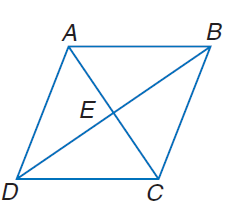Answer the mathemtical geometry problem and directly provide the correct option letter.
Question: In rhombus A B C D, A B = 2 x + 3 and B C = 5 x. Find m \angle B C D if m \angle A B C = 83.2.
Choices: A: 83.2 B: 86.8 C: 93.2 D: 96.8 D 